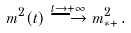<formula> <loc_0><loc_0><loc_500><loc_500>m ^ { 2 } ( t ) \stackrel { t \to + \infty } { \longrightarrow } m ^ { 2 } _ { * + } \, .</formula> 